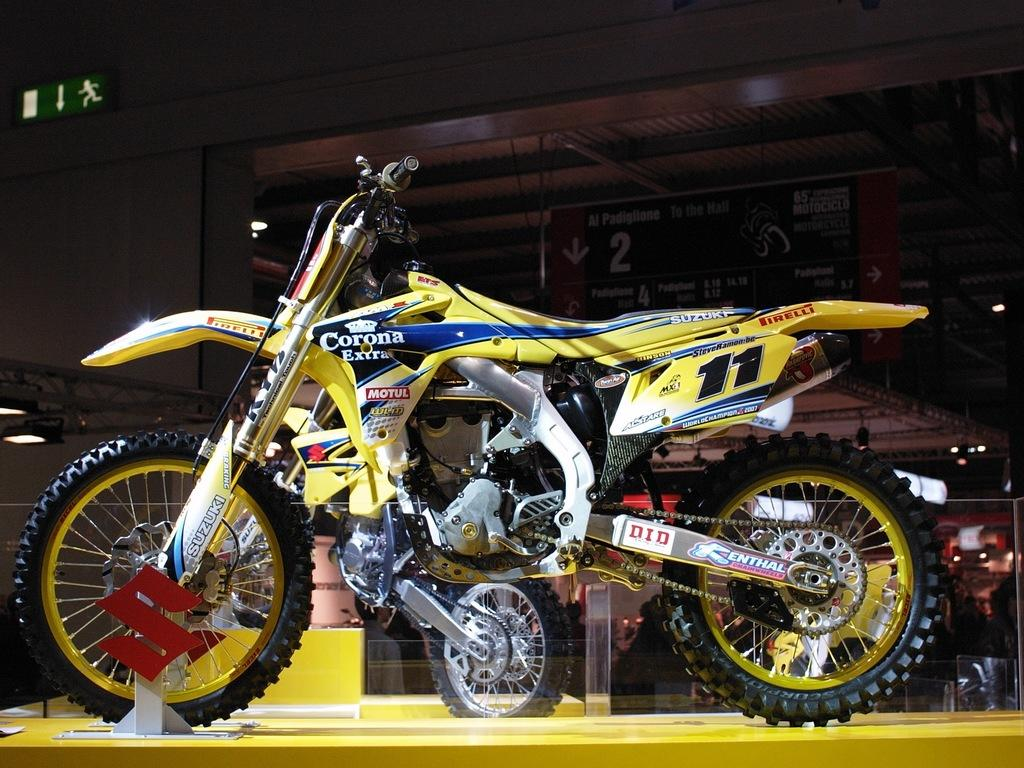What is the main subject in the center of the image? There is a yellow color bike in the center of the image. What can be seen in the background of the image? There is a wall in the background of the image. What is the board with text used for in the image? The board with text might be used for displaying information or advertising. How many stitches are visible on the bike's tires in the image? There are no stitches visible on the bike's tires in the image, as the bike is not a sewn object. 